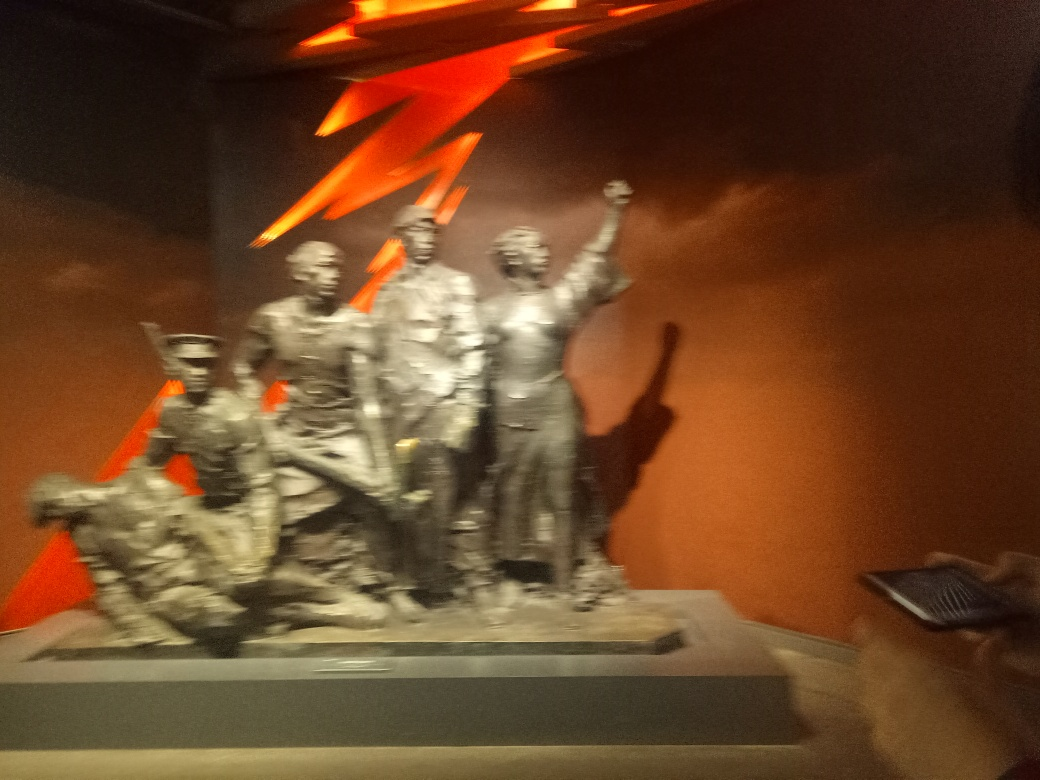Can you describe what the sculpture might represent? The sculpture seems to depict a group of individuals in a victorious or celebratory pose, possibly commemorating an event of historical significance, such as a revolution, battle victory, or a symbolic gesture of unity and strength. 